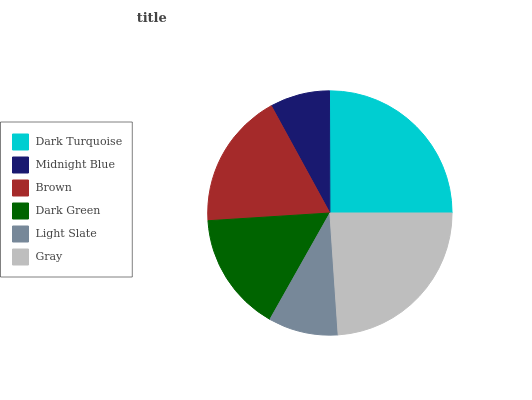Is Midnight Blue the minimum?
Answer yes or no. Yes. Is Dark Turquoise the maximum?
Answer yes or no. Yes. Is Brown the minimum?
Answer yes or no. No. Is Brown the maximum?
Answer yes or no. No. Is Brown greater than Midnight Blue?
Answer yes or no. Yes. Is Midnight Blue less than Brown?
Answer yes or no. Yes. Is Midnight Blue greater than Brown?
Answer yes or no. No. Is Brown less than Midnight Blue?
Answer yes or no. No. Is Brown the high median?
Answer yes or no. Yes. Is Dark Green the low median?
Answer yes or no. Yes. Is Midnight Blue the high median?
Answer yes or no. No. Is Brown the low median?
Answer yes or no. No. 